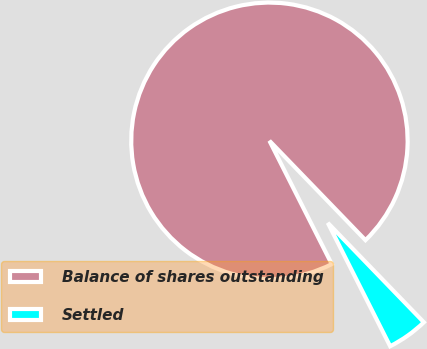<chart> <loc_0><loc_0><loc_500><loc_500><pie_chart><fcel>Balance of shares outstanding<fcel>Settled<nl><fcel>95.22%<fcel>4.78%<nl></chart> 